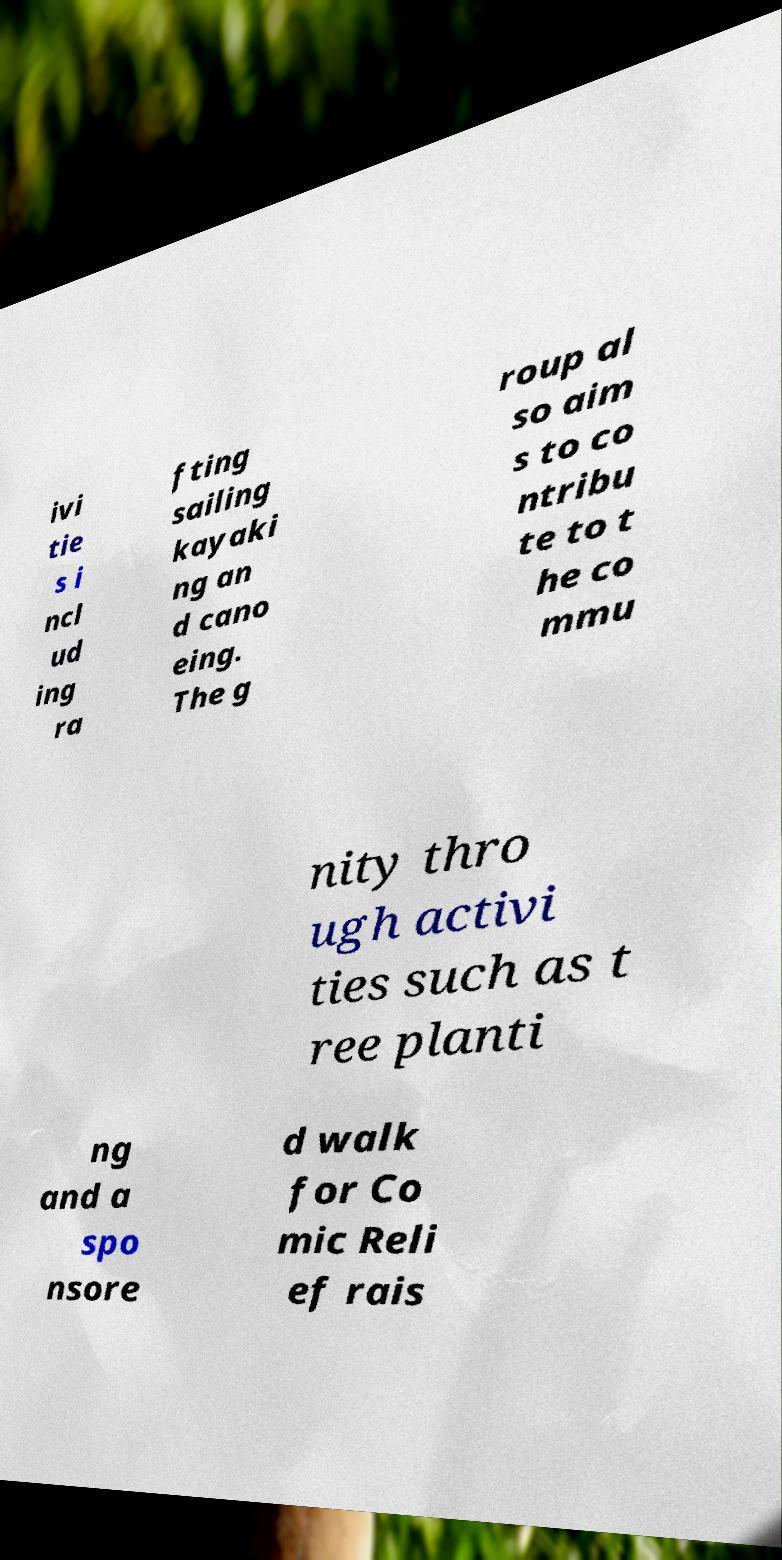Could you assist in decoding the text presented in this image and type it out clearly? ivi tie s i ncl ud ing ra fting sailing kayaki ng an d cano eing. The g roup al so aim s to co ntribu te to t he co mmu nity thro ugh activi ties such as t ree planti ng and a spo nsore d walk for Co mic Reli ef rais 